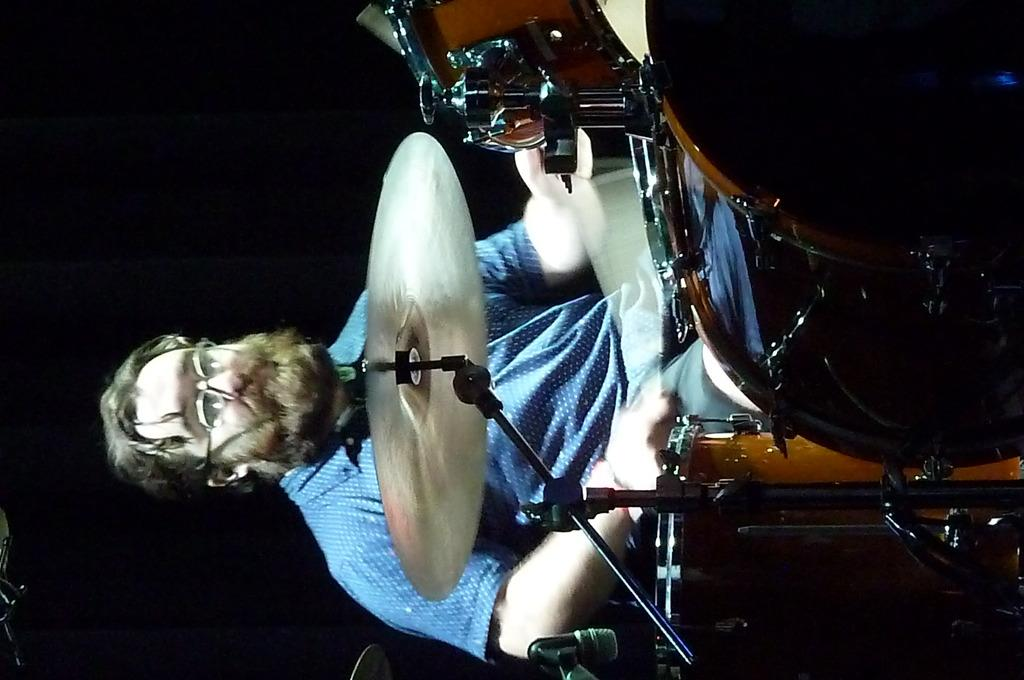What is the main object in the middle of the image? There are drums in the middle of the image. Who is interacting with the drums in the image? A man is sitting behind the drums. What is the man doing with the drums? The man is playing the drums. What type of trade is being conducted in the image? There is no trade being conducted in the image; it features a man playing drums. What kind of test is the man taking while playing the drums? There is no test being taken in the image; the man is simply playing the drums. 